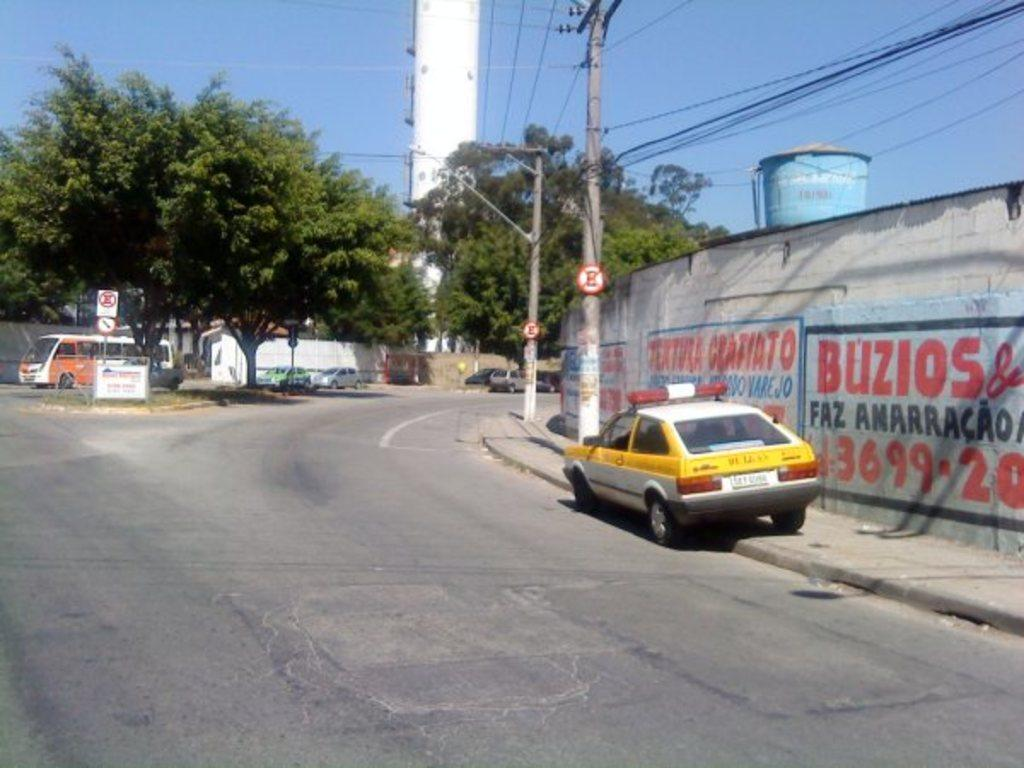<image>
Summarize the visual content of the image. A yellow and white car with lights on top next to a sign that says Buzios. 